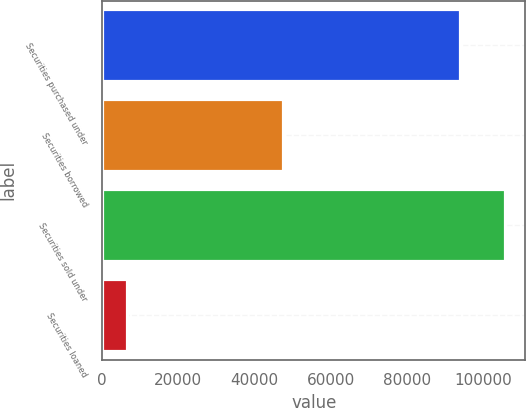Convert chart to OTSL. <chart><loc_0><loc_0><loc_500><loc_500><bar_chart><fcel>Securities purchased under<fcel>Securities borrowed<fcel>Securities sold under<fcel>Securities loaned<nl><fcel>94076<fcel>47428<fcel>105912<fcel>6435<nl></chart> 